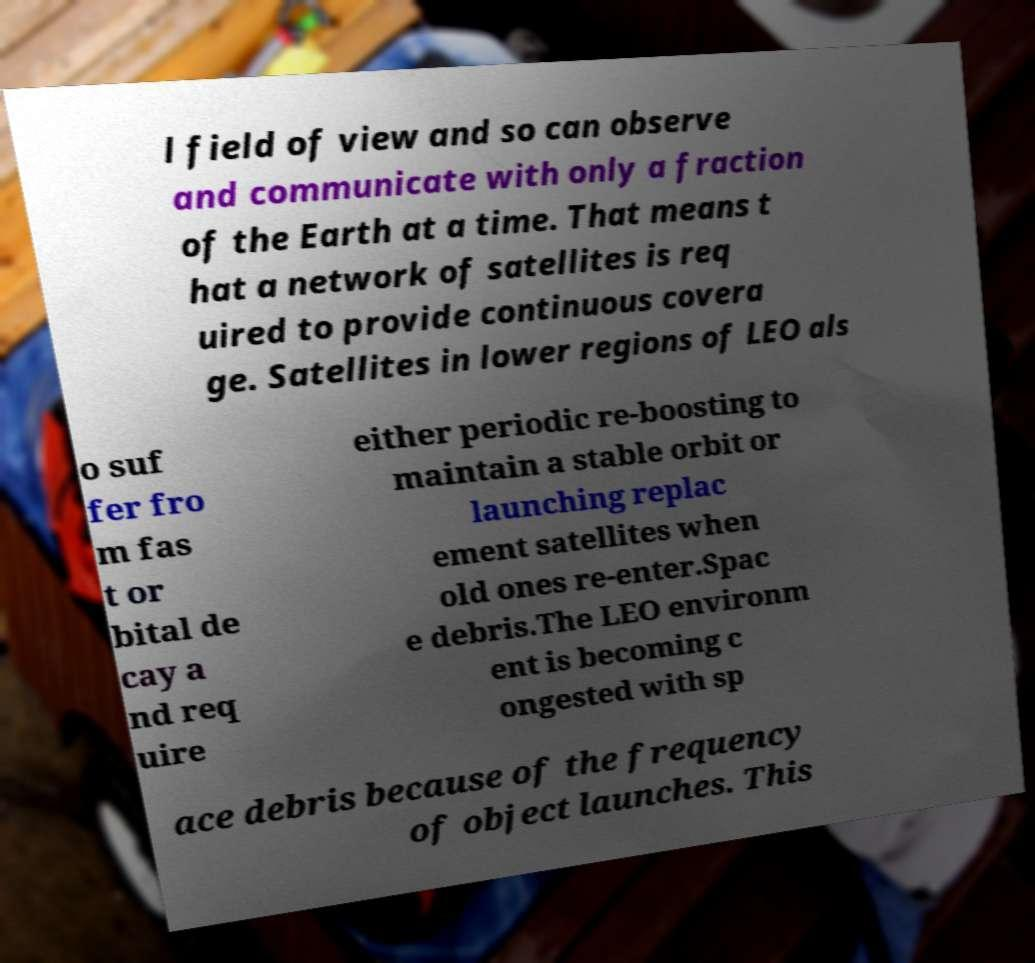Can you read and provide the text displayed in the image?This photo seems to have some interesting text. Can you extract and type it out for me? l field of view and so can observe and communicate with only a fraction of the Earth at a time. That means t hat a network of satellites is req uired to provide continuous covera ge. Satellites in lower regions of LEO als o suf fer fro m fas t or bital de cay a nd req uire either periodic re-boosting to maintain a stable orbit or launching replac ement satellites when old ones re-enter.Spac e debris.The LEO environm ent is becoming c ongested with sp ace debris because of the frequency of object launches. This 